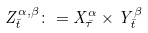<formula> <loc_0><loc_0><loc_500><loc_500>Z ^ { \alpha , \beta } _ { \bar { t } } \colon = X ^ { \alpha } _ { \bar { \tau } } \times Y ^ { \beta } _ { \bar { t } }</formula> 